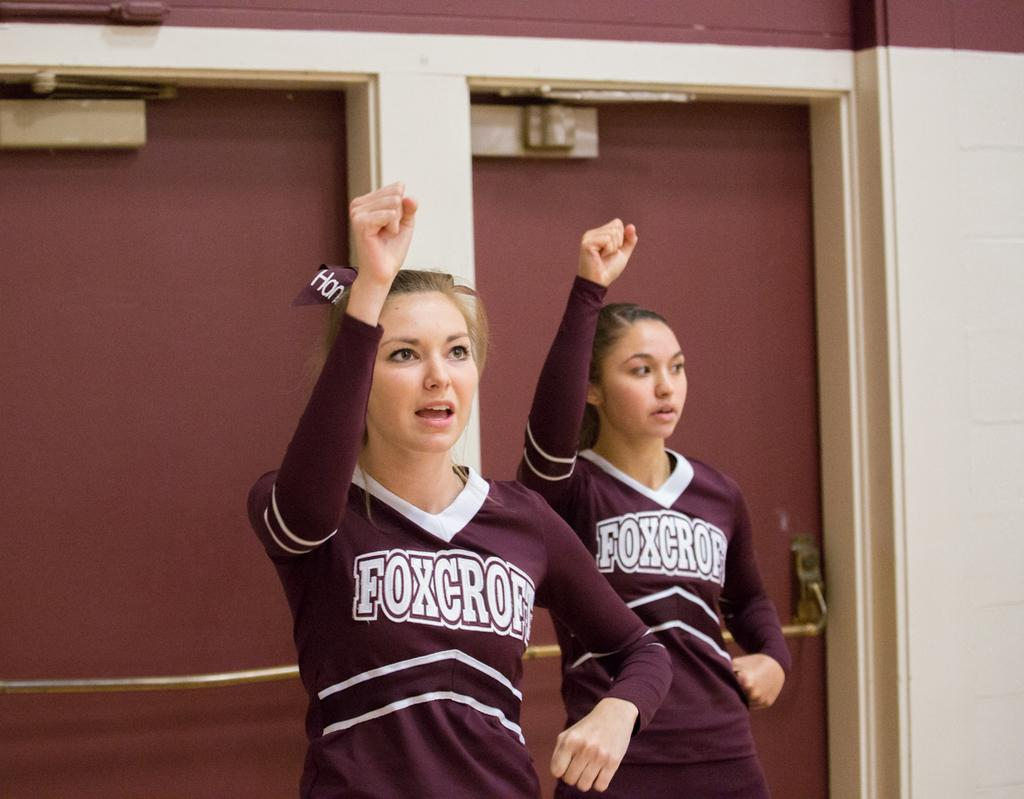Provide a one-sentence caption for the provided image. Froxcroft cheerleaders are raising their right hand up. 